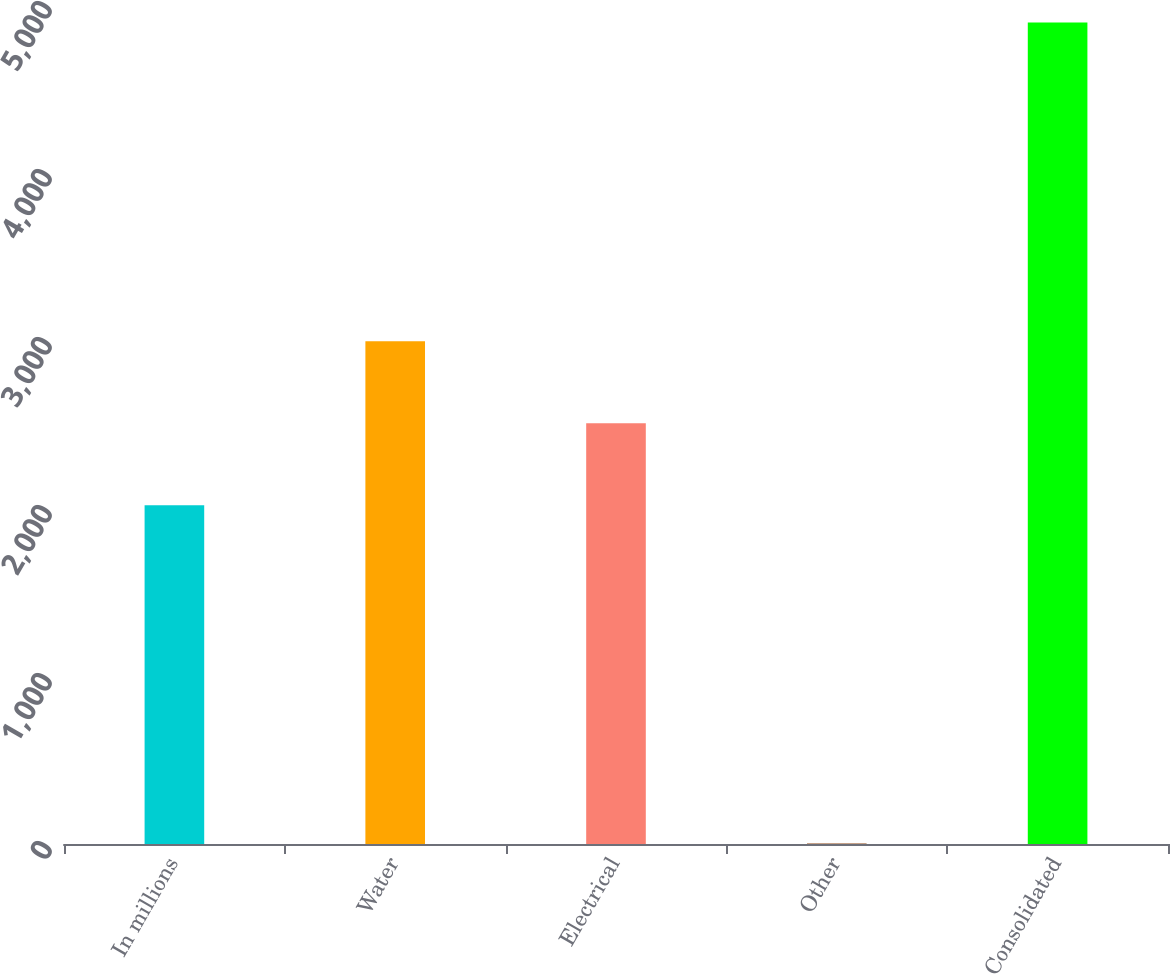Convert chart to OTSL. <chart><loc_0><loc_0><loc_500><loc_500><bar_chart><fcel>In millions<fcel>Water<fcel>Electrical<fcel>Other<fcel>Consolidated<nl><fcel>2016<fcel>2993.26<fcel>2504.63<fcel>3.7<fcel>4890<nl></chart> 